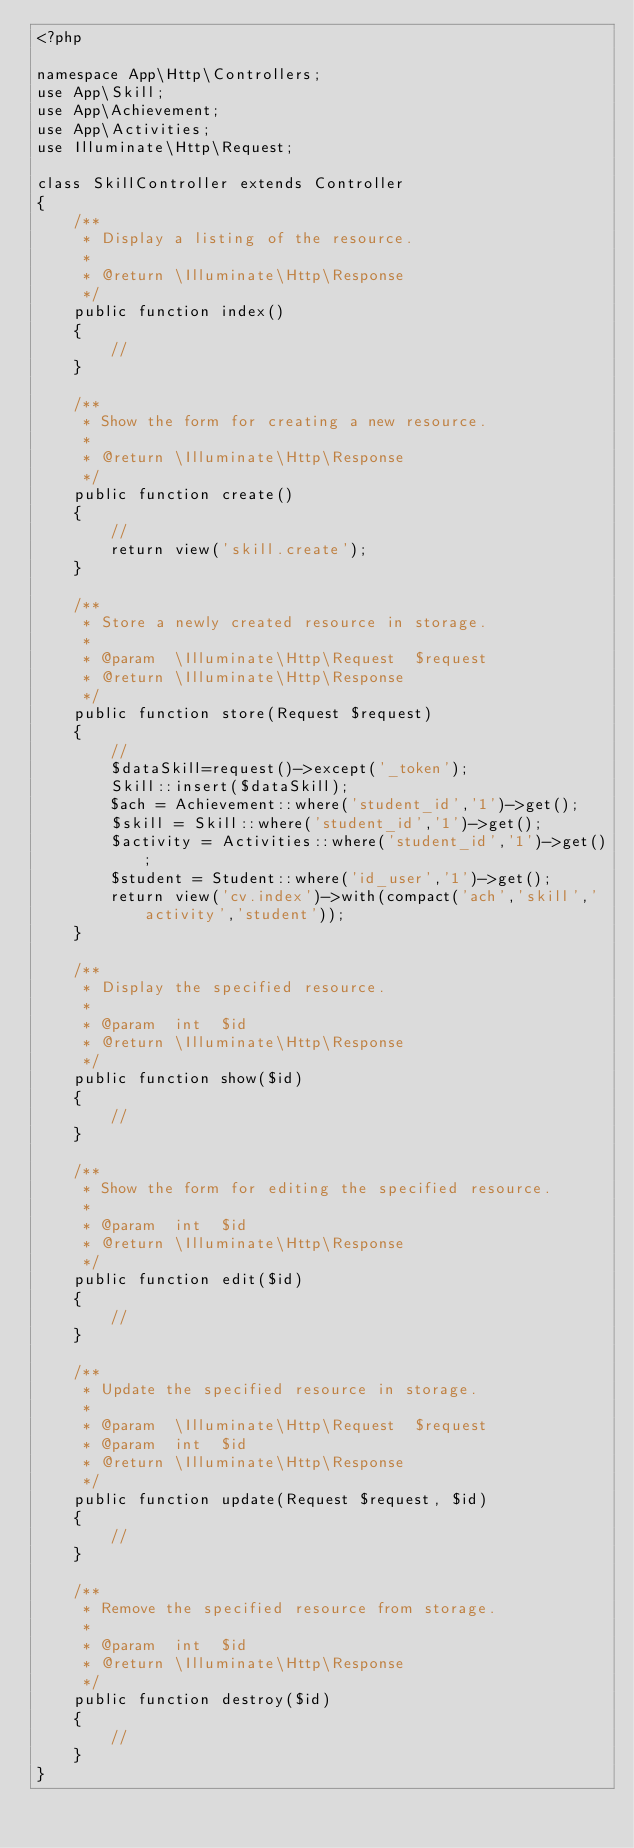<code> <loc_0><loc_0><loc_500><loc_500><_PHP_><?php

namespace App\Http\Controllers;
use App\Skill;
use App\Achievement;
use App\Activities;
use Illuminate\Http\Request;

class SkillController extends Controller
{
    /**
     * Display a listing of the resource.
     *
     * @return \Illuminate\Http\Response
     */
    public function index()
    {
        //
    }

    /**
     * Show the form for creating a new resource.
     *
     * @return \Illuminate\Http\Response
     */
    public function create()
    {
        //
        return view('skill.create');
    }

    /**
     * Store a newly created resource in storage.
     *
     * @param  \Illuminate\Http\Request  $request
     * @return \Illuminate\Http\Response
     */
    public function store(Request $request)
    {
        //
        $dataSkill=request()->except('_token');
        Skill::insert($dataSkill);
        $ach = Achievement::where('student_id','1')->get();
        $skill = Skill::where('student_id','1')->get();
        $activity = Activities::where('student_id','1')->get();
        $student = Student::where('id_user','1')->get();
        return view('cv.index')->with(compact('ach','skill','activity','student'));
    }

    /**
     * Display the specified resource.
     *
     * @param  int  $id
     * @return \Illuminate\Http\Response
     */
    public function show($id)
    {
        //
    }

    /**
     * Show the form for editing the specified resource.
     *
     * @param  int  $id
     * @return \Illuminate\Http\Response
     */
    public function edit($id)
    {
        //
    }

    /**
     * Update the specified resource in storage.
     *
     * @param  \Illuminate\Http\Request  $request
     * @param  int  $id
     * @return \Illuminate\Http\Response
     */
    public function update(Request $request, $id)
    {
        //
    }

    /**
     * Remove the specified resource from storage.
     *
     * @param  int  $id
     * @return \Illuminate\Http\Response
     */
    public function destroy($id)
    {
        //
    }
}
</code> 